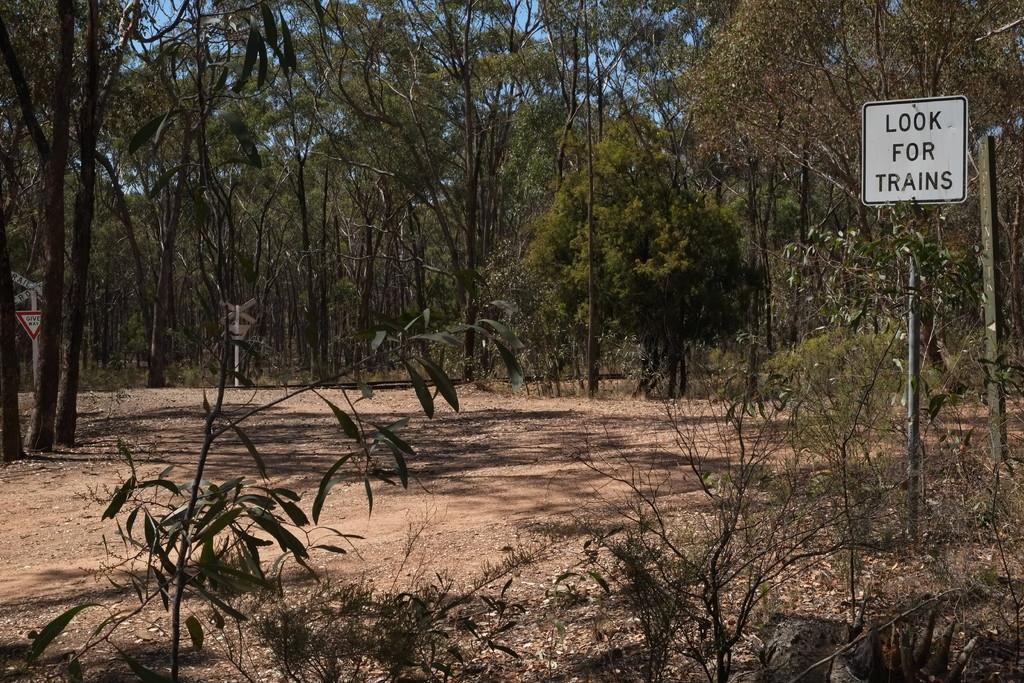Please provide a concise description of this image. In this image, we can see some green plants and trees, on the right side, we can see a white color sign board, we can see the sand on the ground. 